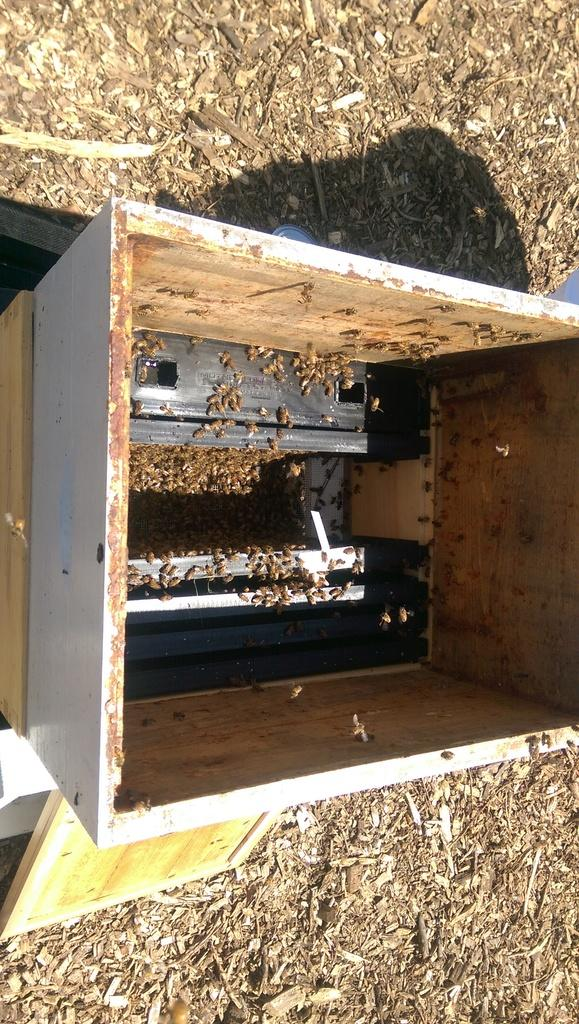What is the main object in the image? There is a beehive box in the image. Where is the beehive box located? The beehive box is on the ground. Can you see any windows in the image? There are no windows present in the image; it features a beehive box on the ground. Is there any exchange happening in the image? There is no exchange or interaction between subjects in the image; it only shows a beehive box on the ground. 